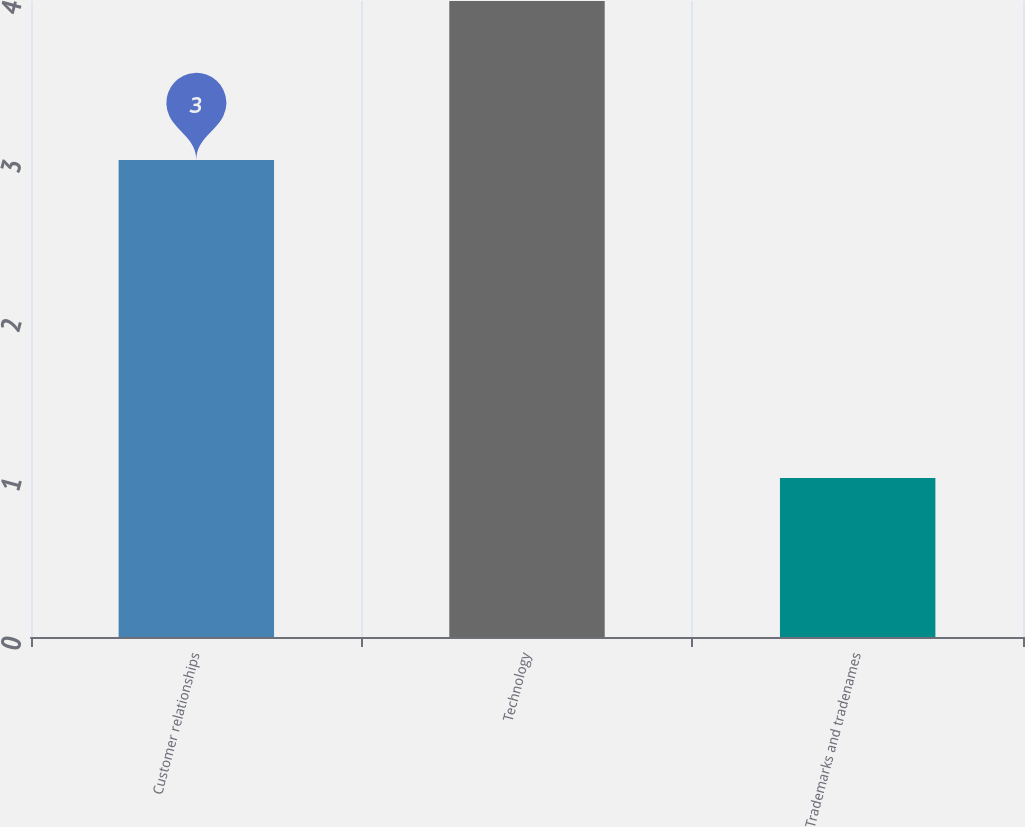Convert chart to OTSL. <chart><loc_0><loc_0><loc_500><loc_500><bar_chart><fcel>Customer relationships<fcel>Technology<fcel>Trademarks and tradenames<nl><fcel>3<fcel>4<fcel>1<nl></chart> 